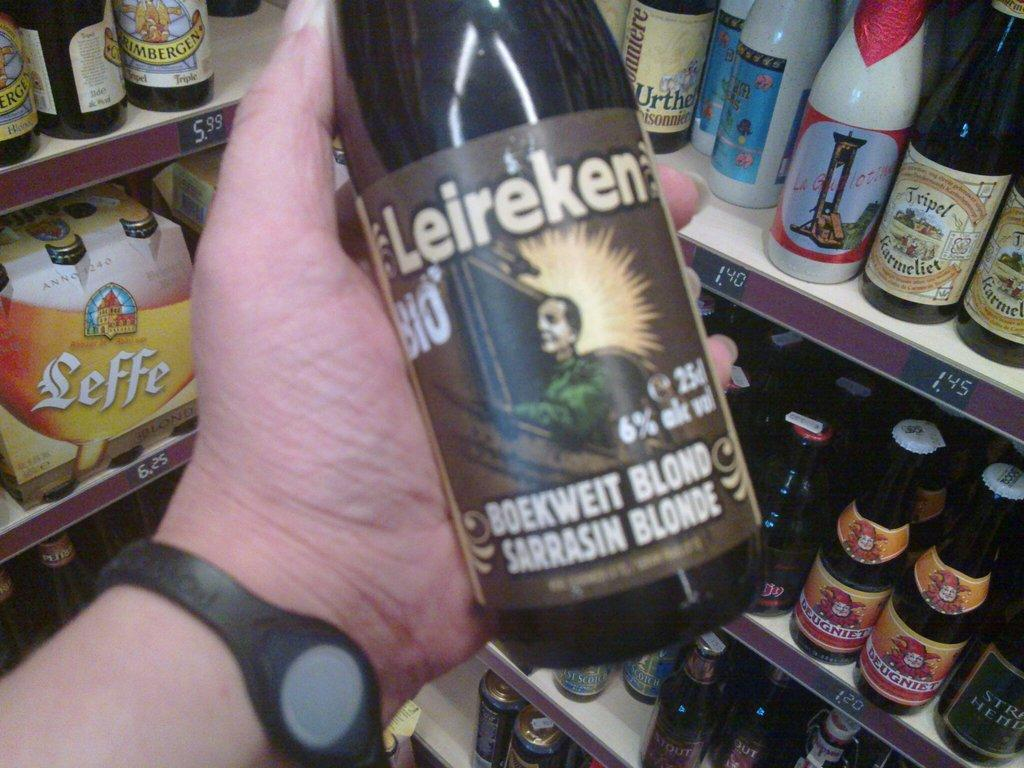<image>
Describe the image concisely. A person holding a bottle of Leireken beer. 